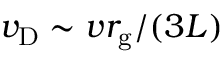Convert formula to latex. <formula><loc_0><loc_0><loc_500><loc_500>v _ { D } \sim v r _ { g } / ( 3 L )</formula> 